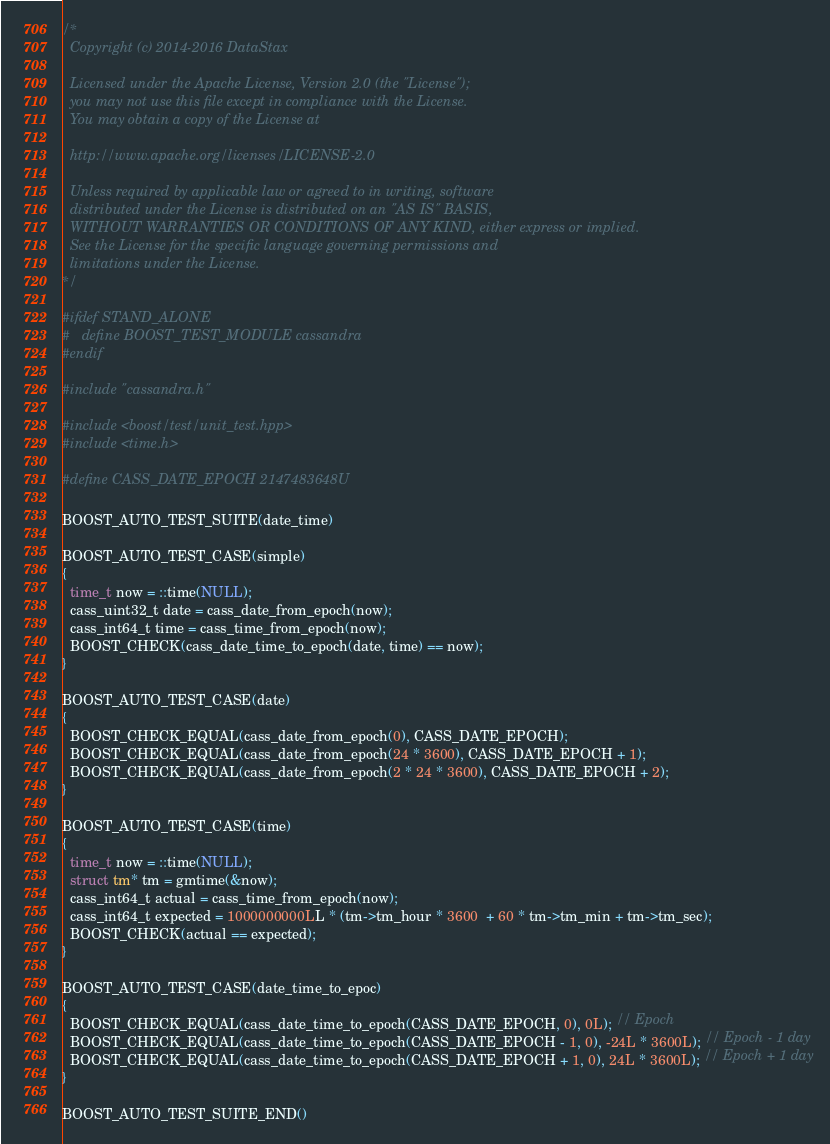Convert code to text. <code><loc_0><loc_0><loc_500><loc_500><_C++_>/*
  Copyright (c) 2014-2016 DataStax

  Licensed under the Apache License, Version 2.0 (the "License");
  you may not use this file except in compliance with the License.
  You may obtain a copy of the License at

  http://www.apache.org/licenses/LICENSE-2.0

  Unless required by applicable law or agreed to in writing, software
  distributed under the License is distributed on an "AS IS" BASIS,
  WITHOUT WARRANTIES OR CONDITIONS OF ANY KIND, either express or implied.
  See the License for the specific language governing permissions and
  limitations under the License.
*/

#ifdef STAND_ALONE
#   define BOOST_TEST_MODULE cassandra
#endif

#include "cassandra.h"

#include <boost/test/unit_test.hpp>
#include <time.h>

#define CASS_DATE_EPOCH 2147483648U

BOOST_AUTO_TEST_SUITE(date_time)

BOOST_AUTO_TEST_CASE(simple)
{
  time_t now = ::time(NULL);
  cass_uint32_t date = cass_date_from_epoch(now);
  cass_int64_t time = cass_time_from_epoch(now);
  BOOST_CHECK(cass_date_time_to_epoch(date, time) == now);
}

BOOST_AUTO_TEST_CASE(date)
{
  BOOST_CHECK_EQUAL(cass_date_from_epoch(0), CASS_DATE_EPOCH);
  BOOST_CHECK_EQUAL(cass_date_from_epoch(24 * 3600), CASS_DATE_EPOCH + 1);
  BOOST_CHECK_EQUAL(cass_date_from_epoch(2 * 24 * 3600), CASS_DATE_EPOCH + 2);
}

BOOST_AUTO_TEST_CASE(time)
{
  time_t now = ::time(NULL);
  struct tm* tm = gmtime(&now);
  cass_int64_t actual = cass_time_from_epoch(now);
  cass_int64_t expected = 1000000000LL * (tm->tm_hour * 3600  + 60 * tm->tm_min + tm->tm_sec);
  BOOST_CHECK(actual == expected);
}

BOOST_AUTO_TEST_CASE(date_time_to_epoc)
{
  BOOST_CHECK_EQUAL(cass_date_time_to_epoch(CASS_DATE_EPOCH, 0), 0L); // Epoch
  BOOST_CHECK_EQUAL(cass_date_time_to_epoch(CASS_DATE_EPOCH - 1, 0), -24L * 3600L); // Epoch - 1 day
  BOOST_CHECK_EQUAL(cass_date_time_to_epoch(CASS_DATE_EPOCH + 1, 0), 24L * 3600L); // Epoch + 1 day
}

BOOST_AUTO_TEST_SUITE_END()
</code> 